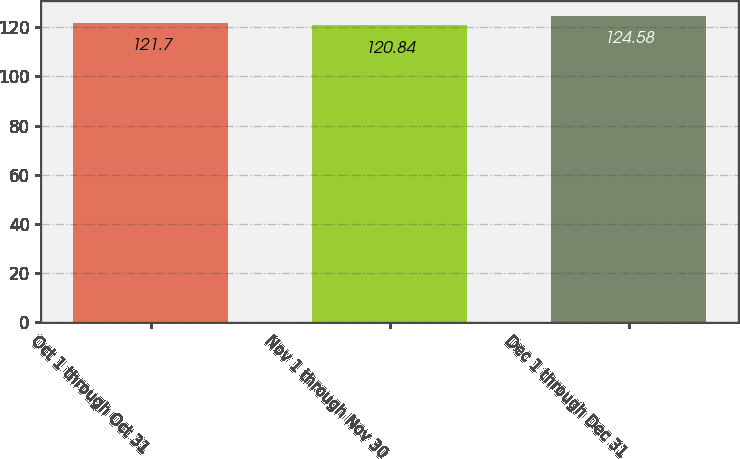<chart> <loc_0><loc_0><loc_500><loc_500><bar_chart><fcel>Oct 1 through Oct 31<fcel>Nov 1 through Nov 30<fcel>Dec 1 through Dec 31<nl><fcel>121.7<fcel>120.84<fcel>124.58<nl></chart> 